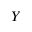<formula> <loc_0><loc_0><loc_500><loc_500>Y</formula> 